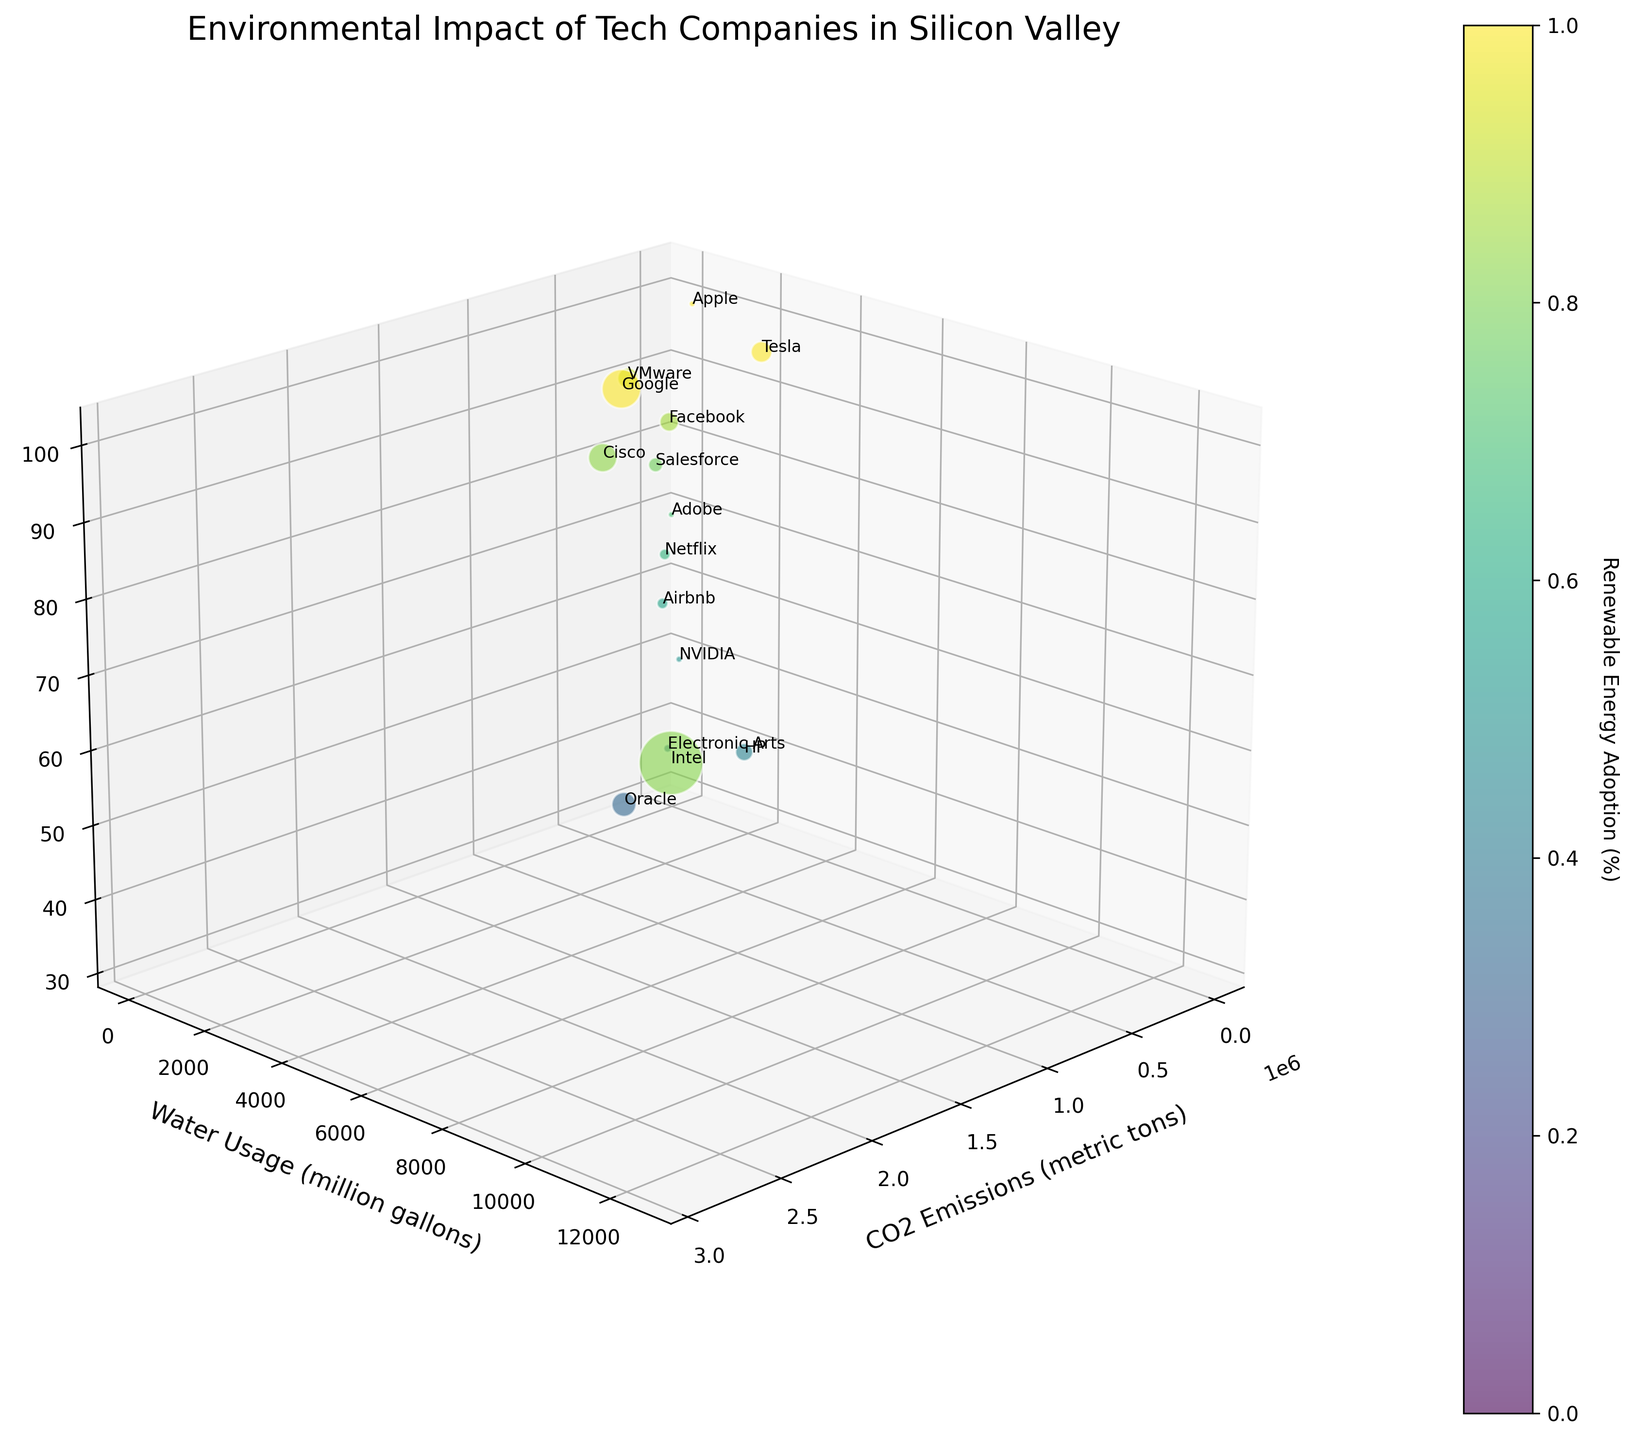What is the title of the plot? The title of the plot is written at the top of the figure. It can be directly read without any calculations or interpretations.
Answer: Environmental Impact of Tech Companies in Silicon Valley Which company has the highest water usage? By observing the y-axis and looking for the data point at the highest position along this axis, we can identify the highest water usage. The company with the highest water usage is Intel.
Answer: Intel Which company has the lowest percentage of renewable energy adoption? By looking at the z-axis and searching for the data point at the lowest position along this axis, we identify the company with the lowest percentage of renewable energy adoption. The company is Oracle.
Answer: Oracle What is the average CO2 emissions of Apple and Google? First, find the CO2 emissions for Apple (25,600) and Google (1,070,000) on the x-axis. Then sum these emissions and divide by 2 to find the average. Average = (25,600 + 1,070,000) / 2 = 547,800.
Answer: 547,800 Which companies have 100% renewable energy adoption? By looking at the z-axis and identifying the data points that are at the topmost level of 100, we find the companies with full renewable energy adoption. These companies are Apple, Google, and Tesla.
Answer: Apple, Google, Tesla Does any company have both lower water usage and higher renewable energy adoption than HP? First, find the position of HP in terms of water usage (2,800) and renewable energy adoption (43%). Then look for any data points with lower water usage and higher renewable energy adoption. Various companies fit this criterion, such as Adobe and Airbnb.
Answer: Adobe, Airbnb Which two companies are closest to each other in terms of CO2 emissions? By observing the x-axis and the points that are closest in distance along this axis, we see that Adobe (26,000) and Apple (25,600) are the nearest.
Answer: Adobe, Apple What is the difference in water usage between Tesla and Facebook? Find the positions of Tesla (3,600) and Facebook (1,020) on the y-axis, then subtract the lower value from the higher value. Difference = 3,600 - 1,020 = 2,580.
Answer: 2,580 Which company has the highest CO2 emissions but less than 50% renewable energy adoption? Look for the highest point on the x-axis and then check the corresponding z-axis value to see if it is below 50%. HP has high CO2 emissions and 43% renewable energy adoption. The highest CO2 emitter, Intel, does not meet the renewable criteria.
Answer: HP 